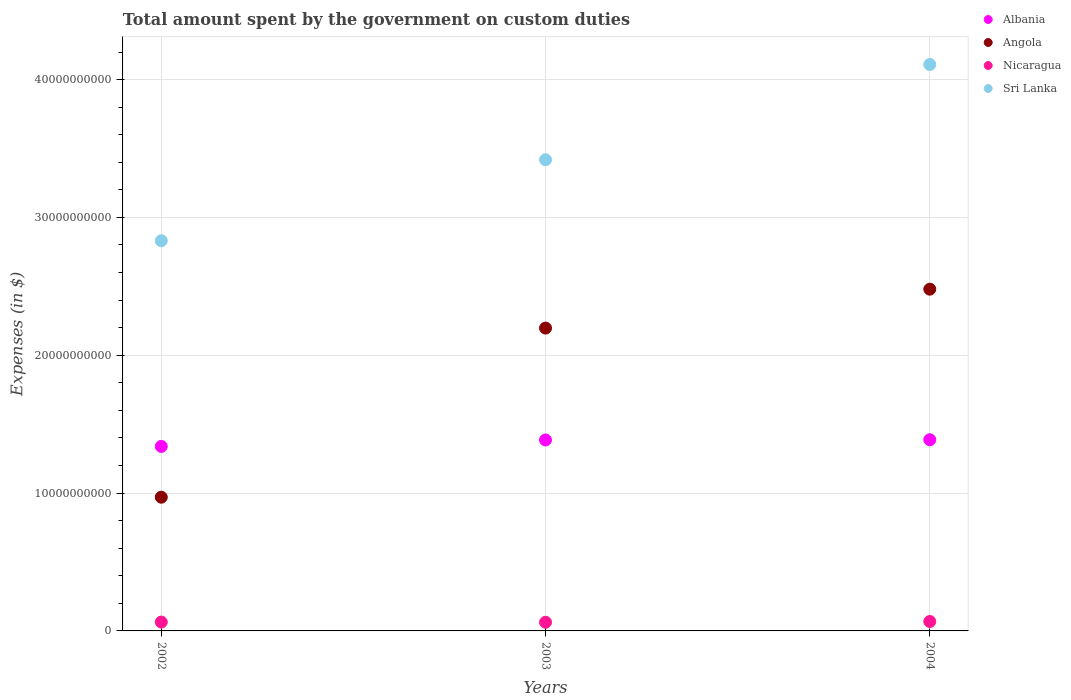What is the amount spent on custom duties by the government in Sri Lanka in 2002?
Your response must be concise. 2.83e+1. Across all years, what is the maximum amount spent on custom duties by the government in Sri Lanka?
Your answer should be very brief. 4.11e+1. Across all years, what is the minimum amount spent on custom duties by the government in Albania?
Your answer should be compact. 1.34e+1. In which year was the amount spent on custom duties by the government in Nicaragua maximum?
Your response must be concise. 2004. What is the total amount spent on custom duties by the government in Albania in the graph?
Provide a succinct answer. 4.11e+1. What is the difference between the amount spent on custom duties by the government in Angola in 2002 and that in 2004?
Your answer should be very brief. -1.51e+1. What is the difference between the amount spent on custom duties by the government in Albania in 2004 and the amount spent on custom duties by the government in Nicaragua in 2002?
Provide a succinct answer. 1.32e+1. What is the average amount spent on custom duties by the government in Albania per year?
Keep it short and to the point. 1.37e+1. In the year 2004, what is the difference between the amount spent on custom duties by the government in Nicaragua and amount spent on custom duties by the government in Angola?
Provide a succinct answer. -2.41e+1. What is the ratio of the amount spent on custom duties by the government in Sri Lanka in 2002 to that in 2004?
Make the answer very short. 0.69. What is the difference between the highest and the second highest amount spent on custom duties by the government in Angola?
Ensure brevity in your answer.  2.82e+09. What is the difference between the highest and the lowest amount spent on custom duties by the government in Sri Lanka?
Provide a succinct answer. 1.28e+1. Is the sum of the amount spent on custom duties by the government in Angola in 2002 and 2003 greater than the maximum amount spent on custom duties by the government in Albania across all years?
Your answer should be very brief. Yes. Is it the case that in every year, the sum of the amount spent on custom duties by the government in Angola and amount spent on custom duties by the government in Nicaragua  is greater than the sum of amount spent on custom duties by the government in Albania and amount spent on custom duties by the government in Sri Lanka?
Give a very brief answer. No. Is it the case that in every year, the sum of the amount spent on custom duties by the government in Sri Lanka and amount spent on custom duties by the government in Albania  is greater than the amount spent on custom duties by the government in Angola?
Offer a very short reply. Yes. Is the amount spent on custom duties by the government in Sri Lanka strictly less than the amount spent on custom duties by the government in Angola over the years?
Keep it short and to the point. No. How many dotlines are there?
Ensure brevity in your answer.  4. How many years are there in the graph?
Your response must be concise. 3. What is the difference between two consecutive major ticks on the Y-axis?
Give a very brief answer. 1.00e+1. Are the values on the major ticks of Y-axis written in scientific E-notation?
Ensure brevity in your answer.  No. Does the graph contain any zero values?
Offer a terse response. No. Does the graph contain grids?
Your response must be concise. Yes. Where does the legend appear in the graph?
Ensure brevity in your answer.  Top right. What is the title of the graph?
Your answer should be compact. Total amount spent by the government on custom duties. Does "Poland" appear as one of the legend labels in the graph?
Keep it short and to the point. No. What is the label or title of the Y-axis?
Give a very brief answer. Expenses (in $). What is the Expenses (in $) of Albania in 2002?
Give a very brief answer. 1.34e+1. What is the Expenses (in $) of Angola in 2002?
Offer a very short reply. 9.70e+09. What is the Expenses (in $) in Nicaragua in 2002?
Your response must be concise. 6.42e+08. What is the Expenses (in $) of Sri Lanka in 2002?
Your response must be concise. 2.83e+1. What is the Expenses (in $) of Albania in 2003?
Offer a terse response. 1.39e+1. What is the Expenses (in $) in Angola in 2003?
Your answer should be compact. 2.20e+1. What is the Expenses (in $) in Nicaragua in 2003?
Your answer should be compact. 6.28e+08. What is the Expenses (in $) in Sri Lanka in 2003?
Your response must be concise. 3.42e+1. What is the Expenses (in $) in Albania in 2004?
Your answer should be compact. 1.39e+1. What is the Expenses (in $) of Angola in 2004?
Offer a very short reply. 2.48e+1. What is the Expenses (in $) of Nicaragua in 2004?
Your answer should be very brief. 6.84e+08. What is the Expenses (in $) in Sri Lanka in 2004?
Offer a very short reply. 4.11e+1. Across all years, what is the maximum Expenses (in $) in Albania?
Offer a terse response. 1.39e+1. Across all years, what is the maximum Expenses (in $) in Angola?
Ensure brevity in your answer.  2.48e+1. Across all years, what is the maximum Expenses (in $) of Nicaragua?
Give a very brief answer. 6.84e+08. Across all years, what is the maximum Expenses (in $) of Sri Lanka?
Offer a terse response. 4.11e+1. Across all years, what is the minimum Expenses (in $) of Albania?
Provide a short and direct response. 1.34e+1. Across all years, what is the minimum Expenses (in $) in Angola?
Provide a short and direct response. 9.70e+09. Across all years, what is the minimum Expenses (in $) of Nicaragua?
Provide a succinct answer. 6.28e+08. Across all years, what is the minimum Expenses (in $) of Sri Lanka?
Give a very brief answer. 2.83e+1. What is the total Expenses (in $) in Albania in the graph?
Make the answer very short. 4.11e+1. What is the total Expenses (in $) in Angola in the graph?
Offer a very short reply. 5.65e+1. What is the total Expenses (in $) of Nicaragua in the graph?
Ensure brevity in your answer.  1.95e+09. What is the total Expenses (in $) of Sri Lanka in the graph?
Your response must be concise. 1.04e+11. What is the difference between the Expenses (in $) in Albania in 2002 and that in 2003?
Make the answer very short. -4.67e+08. What is the difference between the Expenses (in $) in Angola in 2002 and that in 2003?
Make the answer very short. -1.23e+1. What is the difference between the Expenses (in $) in Nicaragua in 2002 and that in 2003?
Keep it short and to the point. 1.37e+07. What is the difference between the Expenses (in $) of Sri Lanka in 2002 and that in 2003?
Keep it short and to the point. -5.88e+09. What is the difference between the Expenses (in $) in Albania in 2002 and that in 2004?
Provide a succinct answer. -4.85e+08. What is the difference between the Expenses (in $) of Angola in 2002 and that in 2004?
Provide a succinct answer. -1.51e+1. What is the difference between the Expenses (in $) of Nicaragua in 2002 and that in 2004?
Offer a terse response. -4.25e+07. What is the difference between the Expenses (in $) in Sri Lanka in 2002 and that in 2004?
Offer a very short reply. -1.28e+1. What is the difference between the Expenses (in $) in Albania in 2003 and that in 2004?
Offer a very short reply. -1.81e+07. What is the difference between the Expenses (in $) in Angola in 2003 and that in 2004?
Give a very brief answer. -2.82e+09. What is the difference between the Expenses (in $) in Nicaragua in 2003 and that in 2004?
Keep it short and to the point. -5.62e+07. What is the difference between the Expenses (in $) in Sri Lanka in 2003 and that in 2004?
Your response must be concise. -6.91e+09. What is the difference between the Expenses (in $) in Albania in 2002 and the Expenses (in $) in Angola in 2003?
Provide a succinct answer. -8.58e+09. What is the difference between the Expenses (in $) of Albania in 2002 and the Expenses (in $) of Nicaragua in 2003?
Give a very brief answer. 1.28e+1. What is the difference between the Expenses (in $) in Albania in 2002 and the Expenses (in $) in Sri Lanka in 2003?
Offer a terse response. -2.08e+1. What is the difference between the Expenses (in $) of Angola in 2002 and the Expenses (in $) of Nicaragua in 2003?
Provide a succinct answer. 9.07e+09. What is the difference between the Expenses (in $) of Angola in 2002 and the Expenses (in $) of Sri Lanka in 2003?
Your answer should be very brief. -2.45e+1. What is the difference between the Expenses (in $) of Nicaragua in 2002 and the Expenses (in $) of Sri Lanka in 2003?
Your answer should be compact. -3.35e+1. What is the difference between the Expenses (in $) of Albania in 2002 and the Expenses (in $) of Angola in 2004?
Offer a terse response. -1.14e+1. What is the difference between the Expenses (in $) of Albania in 2002 and the Expenses (in $) of Nicaragua in 2004?
Provide a succinct answer. 1.27e+1. What is the difference between the Expenses (in $) in Albania in 2002 and the Expenses (in $) in Sri Lanka in 2004?
Ensure brevity in your answer.  -2.77e+1. What is the difference between the Expenses (in $) of Angola in 2002 and the Expenses (in $) of Nicaragua in 2004?
Give a very brief answer. 9.02e+09. What is the difference between the Expenses (in $) of Angola in 2002 and the Expenses (in $) of Sri Lanka in 2004?
Offer a terse response. -3.14e+1. What is the difference between the Expenses (in $) of Nicaragua in 2002 and the Expenses (in $) of Sri Lanka in 2004?
Give a very brief answer. -4.05e+1. What is the difference between the Expenses (in $) in Albania in 2003 and the Expenses (in $) in Angola in 2004?
Provide a short and direct response. -1.09e+1. What is the difference between the Expenses (in $) in Albania in 2003 and the Expenses (in $) in Nicaragua in 2004?
Your response must be concise. 1.32e+1. What is the difference between the Expenses (in $) in Albania in 2003 and the Expenses (in $) in Sri Lanka in 2004?
Give a very brief answer. -2.72e+1. What is the difference between the Expenses (in $) in Angola in 2003 and the Expenses (in $) in Nicaragua in 2004?
Keep it short and to the point. 2.13e+1. What is the difference between the Expenses (in $) in Angola in 2003 and the Expenses (in $) in Sri Lanka in 2004?
Offer a terse response. -1.91e+1. What is the difference between the Expenses (in $) of Nicaragua in 2003 and the Expenses (in $) of Sri Lanka in 2004?
Your response must be concise. -4.05e+1. What is the average Expenses (in $) of Albania per year?
Provide a succinct answer. 1.37e+1. What is the average Expenses (in $) in Angola per year?
Your response must be concise. 1.88e+1. What is the average Expenses (in $) in Nicaragua per year?
Offer a terse response. 6.52e+08. What is the average Expenses (in $) in Sri Lanka per year?
Your answer should be very brief. 3.45e+1. In the year 2002, what is the difference between the Expenses (in $) of Albania and Expenses (in $) of Angola?
Give a very brief answer. 3.68e+09. In the year 2002, what is the difference between the Expenses (in $) of Albania and Expenses (in $) of Nicaragua?
Your answer should be very brief. 1.27e+1. In the year 2002, what is the difference between the Expenses (in $) in Albania and Expenses (in $) in Sri Lanka?
Provide a short and direct response. -1.49e+1. In the year 2002, what is the difference between the Expenses (in $) in Angola and Expenses (in $) in Nicaragua?
Give a very brief answer. 9.06e+09. In the year 2002, what is the difference between the Expenses (in $) of Angola and Expenses (in $) of Sri Lanka?
Keep it short and to the point. -1.86e+1. In the year 2002, what is the difference between the Expenses (in $) in Nicaragua and Expenses (in $) in Sri Lanka?
Your response must be concise. -2.77e+1. In the year 2003, what is the difference between the Expenses (in $) of Albania and Expenses (in $) of Angola?
Provide a succinct answer. -8.12e+09. In the year 2003, what is the difference between the Expenses (in $) in Albania and Expenses (in $) in Nicaragua?
Provide a short and direct response. 1.32e+1. In the year 2003, what is the difference between the Expenses (in $) of Albania and Expenses (in $) of Sri Lanka?
Keep it short and to the point. -2.03e+1. In the year 2003, what is the difference between the Expenses (in $) in Angola and Expenses (in $) in Nicaragua?
Ensure brevity in your answer.  2.13e+1. In the year 2003, what is the difference between the Expenses (in $) of Angola and Expenses (in $) of Sri Lanka?
Ensure brevity in your answer.  -1.22e+1. In the year 2003, what is the difference between the Expenses (in $) in Nicaragua and Expenses (in $) in Sri Lanka?
Give a very brief answer. -3.36e+1. In the year 2004, what is the difference between the Expenses (in $) of Albania and Expenses (in $) of Angola?
Offer a very short reply. -1.09e+1. In the year 2004, what is the difference between the Expenses (in $) in Albania and Expenses (in $) in Nicaragua?
Your answer should be very brief. 1.32e+1. In the year 2004, what is the difference between the Expenses (in $) of Albania and Expenses (in $) of Sri Lanka?
Keep it short and to the point. -2.72e+1. In the year 2004, what is the difference between the Expenses (in $) in Angola and Expenses (in $) in Nicaragua?
Provide a short and direct response. 2.41e+1. In the year 2004, what is the difference between the Expenses (in $) in Angola and Expenses (in $) in Sri Lanka?
Give a very brief answer. -1.63e+1. In the year 2004, what is the difference between the Expenses (in $) of Nicaragua and Expenses (in $) of Sri Lanka?
Provide a short and direct response. -4.04e+1. What is the ratio of the Expenses (in $) in Albania in 2002 to that in 2003?
Ensure brevity in your answer.  0.97. What is the ratio of the Expenses (in $) in Angola in 2002 to that in 2003?
Make the answer very short. 0.44. What is the ratio of the Expenses (in $) in Nicaragua in 2002 to that in 2003?
Your answer should be compact. 1.02. What is the ratio of the Expenses (in $) of Sri Lanka in 2002 to that in 2003?
Provide a succinct answer. 0.83. What is the ratio of the Expenses (in $) in Albania in 2002 to that in 2004?
Give a very brief answer. 0.96. What is the ratio of the Expenses (in $) of Angola in 2002 to that in 2004?
Make the answer very short. 0.39. What is the ratio of the Expenses (in $) of Nicaragua in 2002 to that in 2004?
Give a very brief answer. 0.94. What is the ratio of the Expenses (in $) of Sri Lanka in 2002 to that in 2004?
Ensure brevity in your answer.  0.69. What is the ratio of the Expenses (in $) in Albania in 2003 to that in 2004?
Your response must be concise. 1. What is the ratio of the Expenses (in $) in Angola in 2003 to that in 2004?
Offer a very short reply. 0.89. What is the ratio of the Expenses (in $) of Nicaragua in 2003 to that in 2004?
Give a very brief answer. 0.92. What is the ratio of the Expenses (in $) in Sri Lanka in 2003 to that in 2004?
Give a very brief answer. 0.83. What is the difference between the highest and the second highest Expenses (in $) of Albania?
Your answer should be very brief. 1.81e+07. What is the difference between the highest and the second highest Expenses (in $) of Angola?
Provide a short and direct response. 2.82e+09. What is the difference between the highest and the second highest Expenses (in $) of Nicaragua?
Provide a short and direct response. 4.25e+07. What is the difference between the highest and the second highest Expenses (in $) of Sri Lanka?
Offer a very short reply. 6.91e+09. What is the difference between the highest and the lowest Expenses (in $) in Albania?
Provide a short and direct response. 4.85e+08. What is the difference between the highest and the lowest Expenses (in $) of Angola?
Your response must be concise. 1.51e+1. What is the difference between the highest and the lowest Expenses (in $) in Nicaragua?
Ensure brevity in your answer.  5.62e+07. What is the difference between the highest and the lowest Expenses (in $) in Sri Lanka?
Your response must be concise. 1.28e+1. 